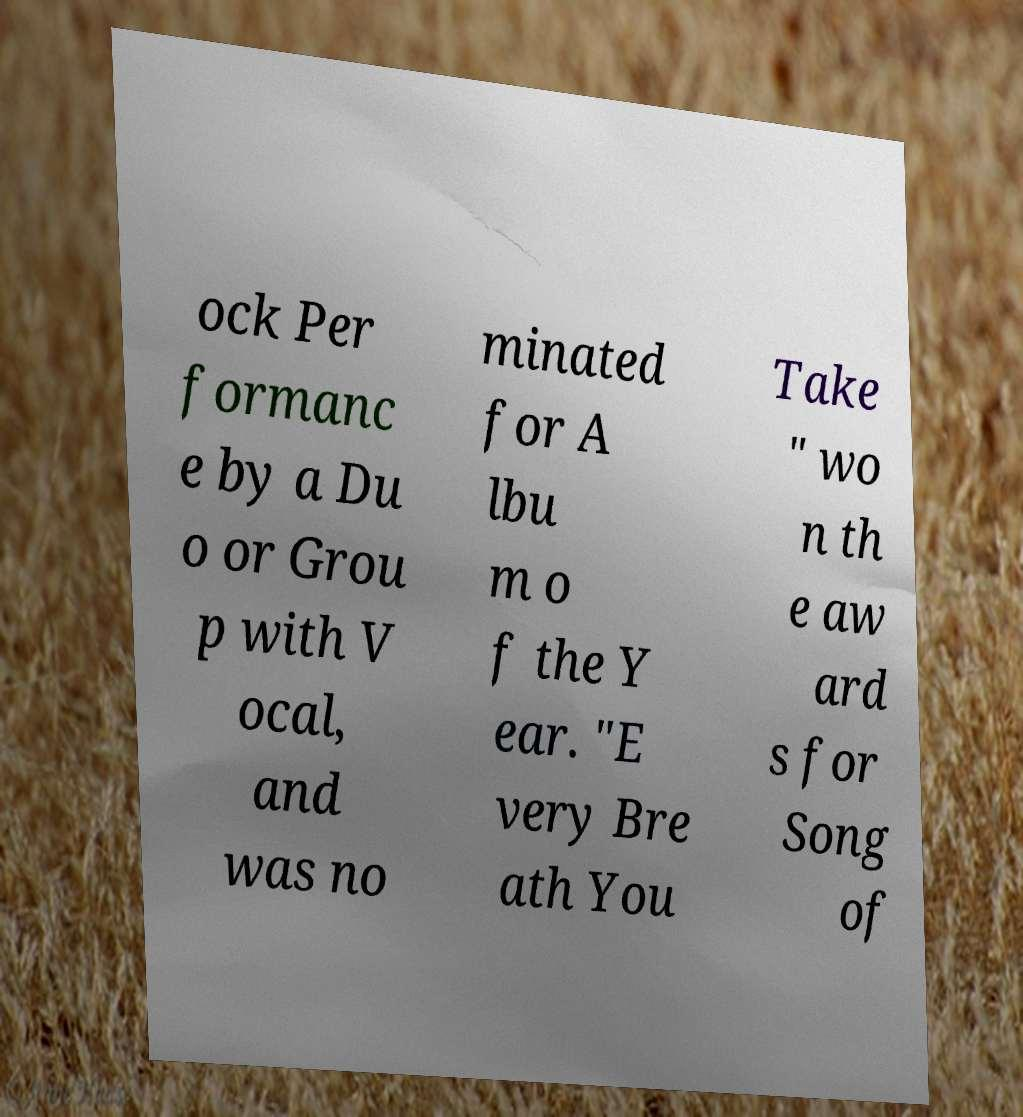I need the written content from this picture converted into text. Can you do that? ock Per formanc e by a Du o or Grou p with V ocal, and was no minated for A lbu m o f the Y ear. "E very Bre ath You Take " wo n th e aw ard s for Song of 